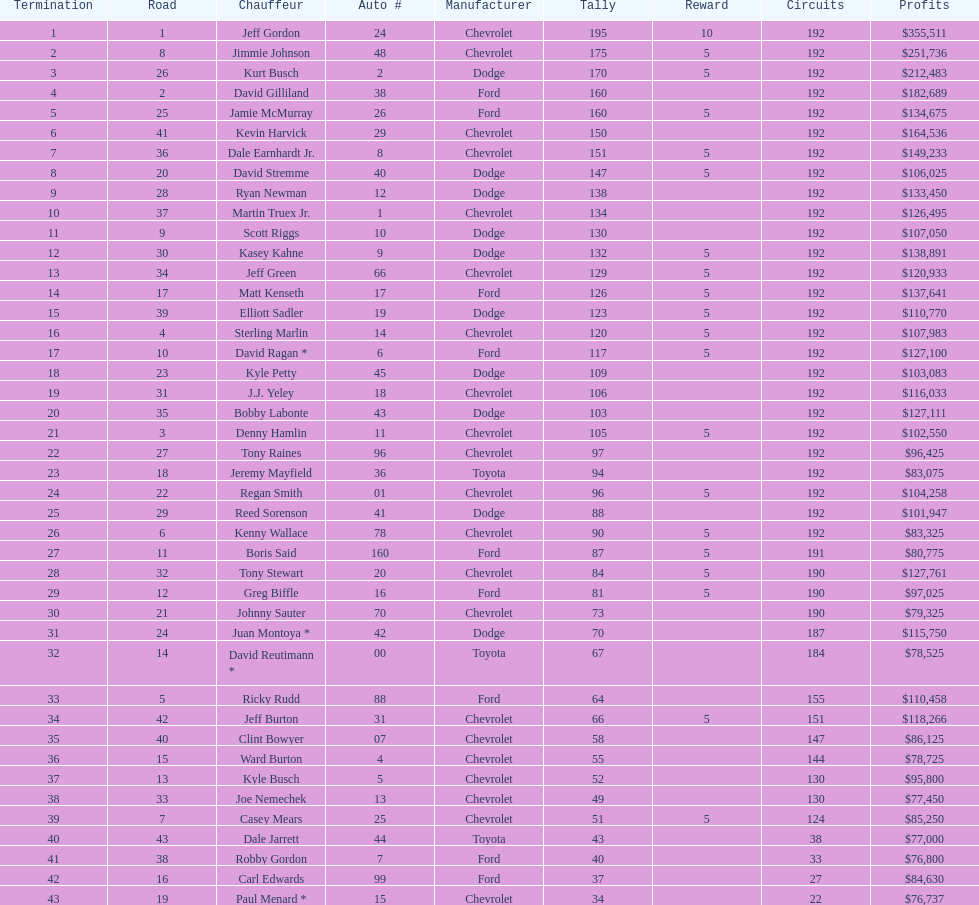What was jimmie johnson's winnings? $251,736. 